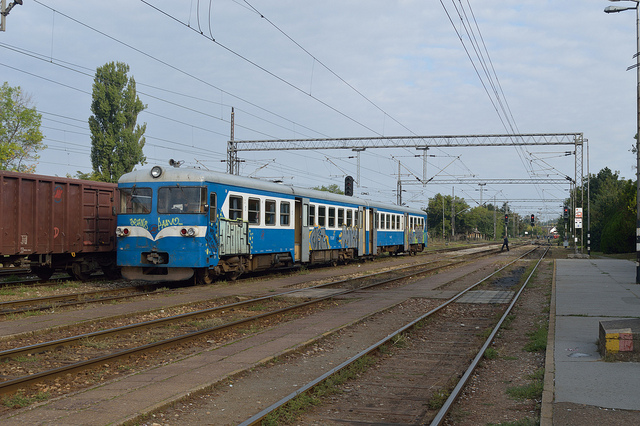<image>Which train has white lights? I don't know which train has white lights. It can be the blue one. Which train has white lights? I don't know which train has white lights. The answer is ambiguous. 